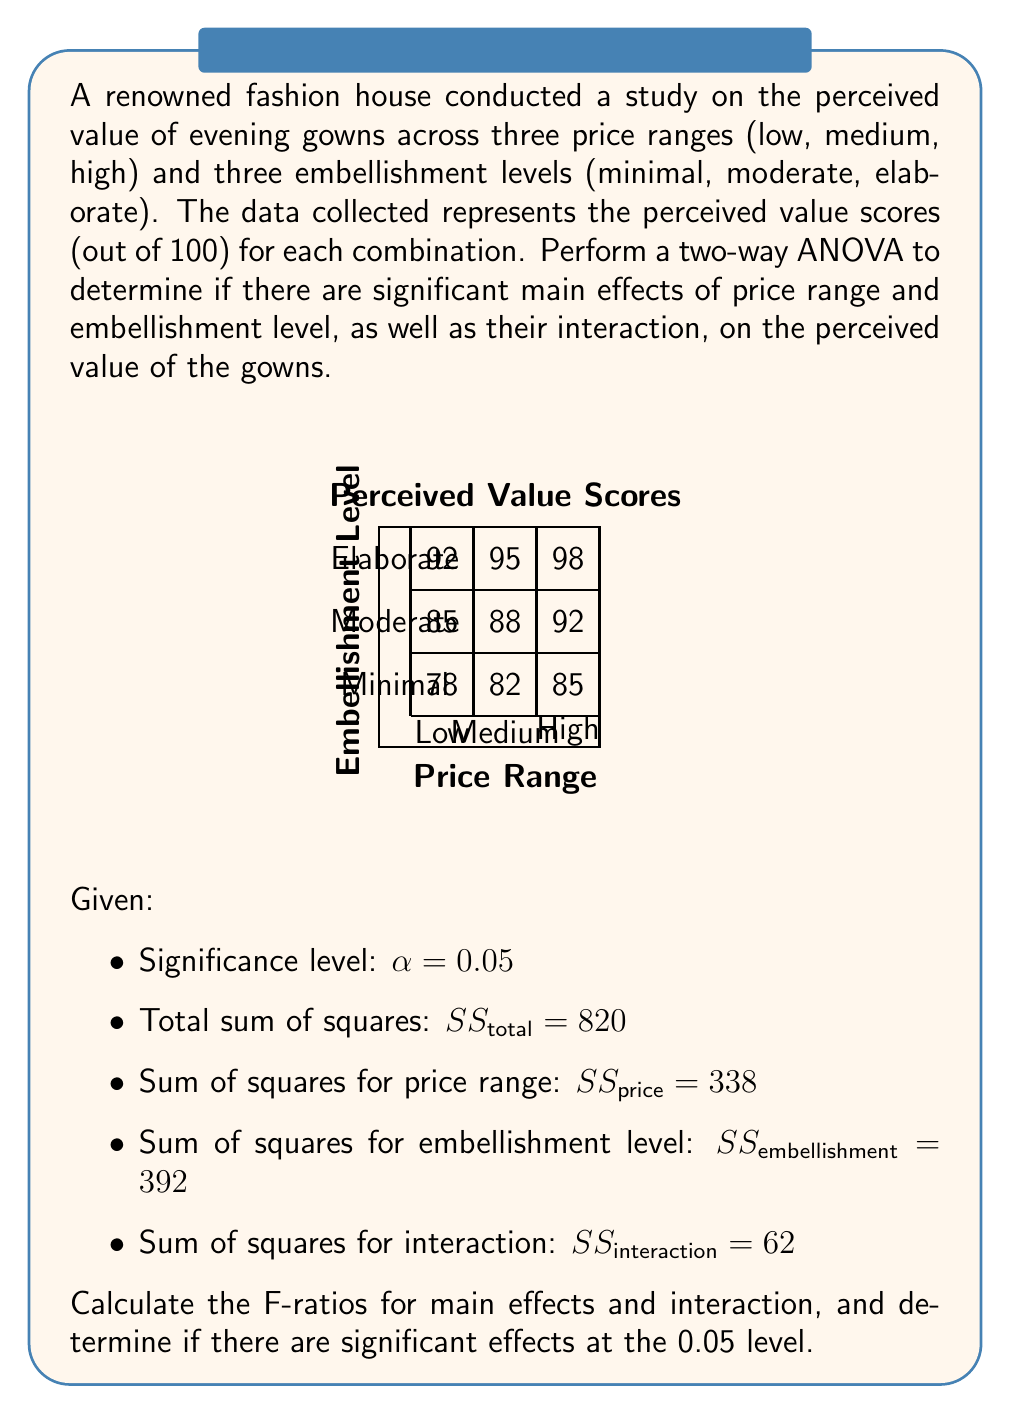Give your solution to this math problem. Let's approach this step-by-step:

1) First, we need to calculate the degrees of freedom (df):
   - $df_{price} = 3 - 1 = 2$ (3 price ranges)
   - $df_{embellishment} = 3 - 1 = 2$ (3 embellishment levels)
   - $df_{interaction} = df_{price} \times df_{embellishment} = 2 \times 2 = 4$
   - $df_{total} = (3 \times 3 \times 3) - 1 = 26$ (3 price ranges, 3 embellishment levels, 3 replications)
   - $df_{error} = df_{total} - df_{price} - df_{embellishment} - df_{interaction} = 26 - 2 - 2 - 4 = 18$

2) Calculate sum of squares for error:
   $SS_{error} = SS_{total} - SS_{price} - SS_{embellishment} - SS_{interaction}$
   $SS_{error} = 820 - 338 - 392 - 62 = 28$

3) Calculate mean squares (MS):
   $MS_{price} = \frac{SS_{price}}{df_{price}} = \frac{338}{2} = 169$
   $MS_{embellishment} = \frac{SS_{embellishment}}{df_{embellishment}} = \frac{392}{2} = 196$
   $MS_{interaction} = \frac{SS_{interaction}}{df_{interaction}} = \frac{62}{4} = 15.5$
   $MS_{error} = \frac{SS_{error}}{df_{error}} = \frac{28}{18} = 1.56$

4) Calculate F-ratios:
   $F_{price} = \frac{MS_{price}}{MS_{error}} = \frac{169}{1.56} = 108.33$
   $F_{embellishment} = \frac{MS_{embellishment}}{MS_{error}} = \frac{196}{1.56} = 125.64$
   $F_{interaction} = \frac{MS_{interaction}}{MS_{error}} = \frac{15.5}{1.56} = 9.94$

5) Determine critical F-values at $\alpha = 0.05$:
   $F_{critical(price)} = F_{0.05,2,18} \approx 3.55$
   $F_{critical(embellishment)} = F_{0.05,2,18} \approx 3.55$
   $F_{critical(interaction)} = F_{0.05,4,18} \approx 2.93$

6) Compare F-ratios to critical F-values:
   All calculated F-ratios are greater than their respective critical F-values.

Therefore, we can conclude that there are significant main effects of both price range and embellishment level, as well as a significant interaction effect between price range and embellishment level on the perceived value of the gowns at the 0.05 significance level.
Answer: Significant main effects of price range ($F = 108.33 > 3.55$) and embellishment level ($F = 125.64 > 3.55$), and significant interaction effect ($F = 9.94 > 2.93$) at $\alpha = 0.05$. 